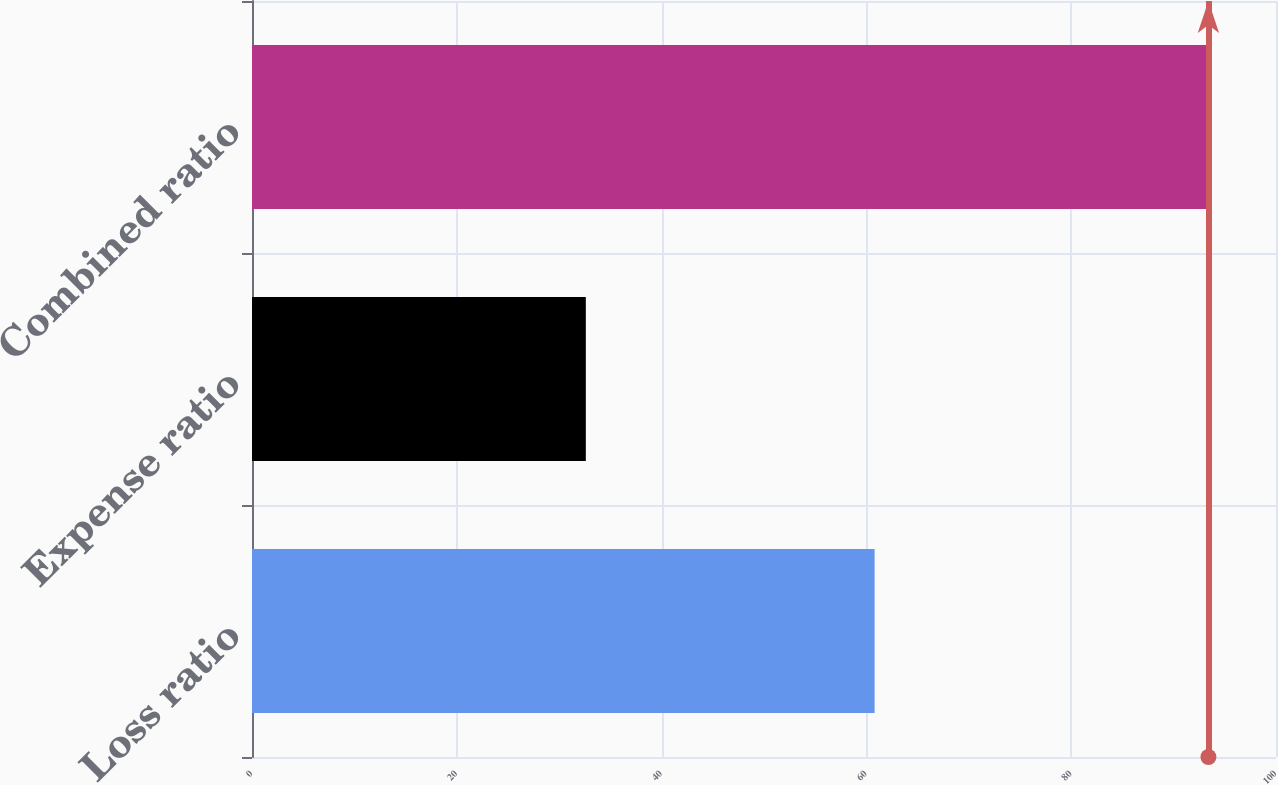Convert chart to OTSL. <chart><loc_0><loc_0><loc_500><loc_500><bar_chart><fcel>Loss ratio<fcel>Expense ratio<fcel>Combined ratio<nl><fcel>60.8<fcel>32.6<fcel>93.4<nl></chart> 